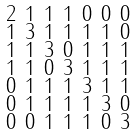<formula> <loc_0><loc_0><loc_500><loc_500>\begin{smallmatrix} 2 & 1 & 1 & 1 & 0 & 0 & 0 \\ 1 & 3 & 1 & 1 & 1 & 1 & 0 \\ 1 & 1 & 3 & 0 & 1 & 1 & 1 \\ 1 & 1 & 0 & 3 & 1 & 1 & 1 \\ 0 & 1 & 1 & 1 & 3 & 1 & 1 \\ 0 & 1 & 1 & 1 & 1 & 3 & 0 \\ 0 & 0 & 1 & 1 & 1 & 0 & 3 \end{smallmatrix}</formula> 